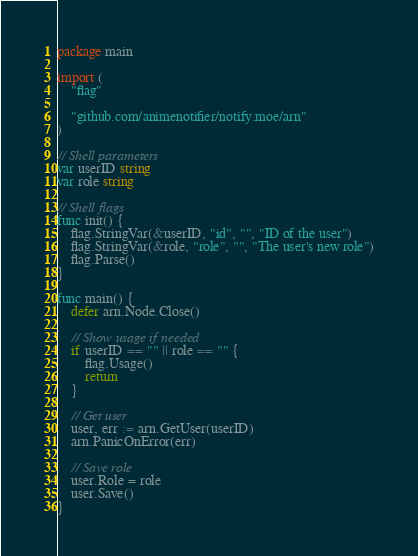<code> <loc_0><loc_0><loc_500><loc_500><_Go_>package main

import (
	"flag"

	"github.com/animenotifier/notify.moe/arn"
)

// Shell parameters
var userID string
var role string

// Shell flags
func init() {
	flag.StringVar(&userID, "id", "", "ID of the user")
	flag.StringVar(&role, "role", "", "The user's new role")
	flag.Parse()
}

func main() {
	defer arn.Node.Close()

	// Show usage if needed
	if userID == "" || role == "" {
		flag.Usage()
		return
	}

	// Get user
	user, err := arn.GetUser(userID)
	arn.PanicOnError(err)

	// Save role
	user.Role = role
	user.Save()
}
</code> 